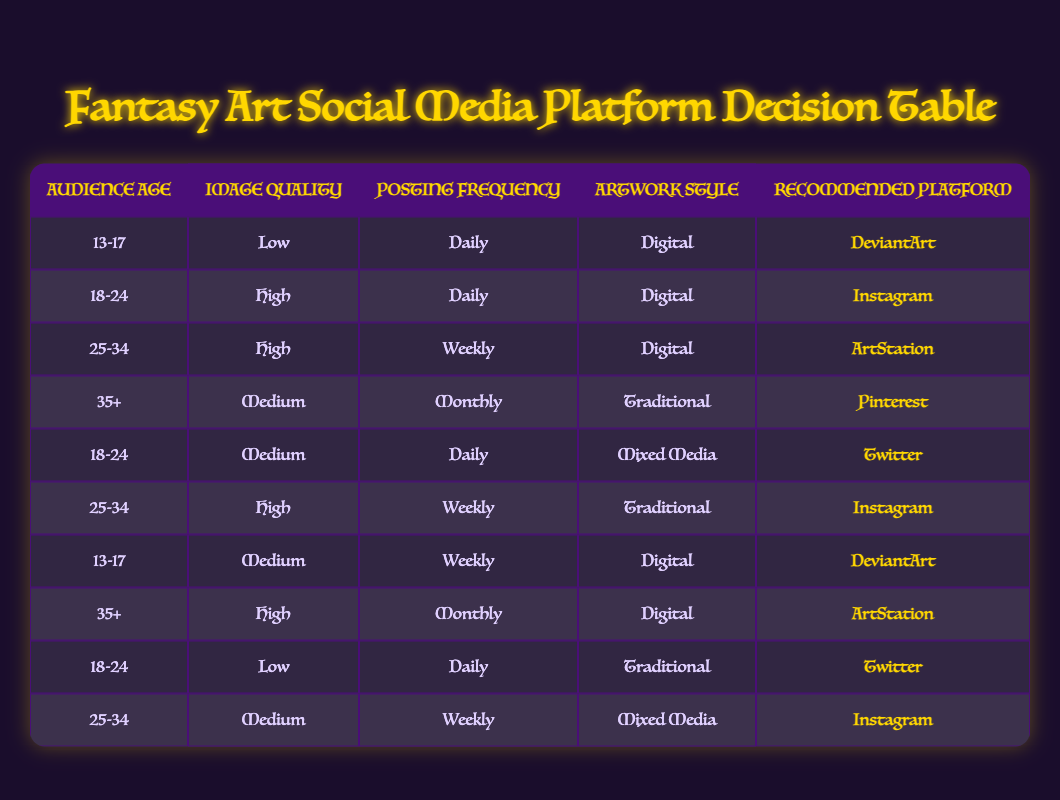What is the recommended platform for 18-24 age group with high image quality and daily posting frequency? According to the table, the conditions match the second row where the audiences are aged 18-24, with high image quality, and posting daily. The recommended platform is Instagram.
Answer: Instagram Which age group is advised to use Pinterest for sharing artwork? Looking at the table, Pinterest is suggested for the 35+ age group with medium image quality and monthly posting frequency, as seen in the fourth row.
Answer: 35+ Is there a recommended platform for 25-34 age group with medium quality and weekly posting frequency? In the table, there is no specific entry for the 25-34 age group with medium quality and weekly frequency; thus, no recommendation exists under these conditions.
Answer: No How many rows suggest DeviantArt as the recommended platform? By counting the rows with DeviantArt in the fifth column, we find two entries: one for 13-17 years with low quality and daily posting, and the other for 13-17 years with medium quality and weekly posting. So, there are two rows suggesting DeviantArt.
Answer: 2 Compare the platforms suggested for digital artwork versus traditional artwork. Which platform is recommended for higher age groups in each artwork style? For digital artwork, the platforms suggested for higher age groups (25-34 and 35+) include ArtStation and Instagram, respectively. For traditional artwork, the 35+ age group is directed towards Pinterest. Thus, Instagram is recommended for higher groups in digital art, and Pinterest in traditional art.
Answer: Instagram for digital, Pinterest for traditional Is Twitter recommended for any low image quality posts? Upon inspecting the table, two entries mention Twitter, but both pertain to Medium or High image quality. Thus, there are no recommendations for low image quality posts on Twitter.
Answer: No What is the common platform recommended for 25-34 age group and high image quality across different posting frequencies? By examining the table, it's evident that for the 25-34 age group with high image quality, Instagram is the common platform recommended when posting frequency is either Weekly (fifth row) or in Traditional style (sixth row).
Answer: Instagram Does a mix of media style for 18-24 age group affect the platform choice? Yes, the table indicates that when the artwork style is Mixed Media for the 18-24 age group, the recommended platform is Twitter. Under other styles (Digital and Traditional), the recommendations differ as well, indicating a notable effect.
Answer: Yes What is the different posting frequency among platforms for all age groups? The data shows a variation in posting frequencies across platforms. Instagram and Twitter suggest daily and weekly frequencies, while DeviantArt and Pinterest recommend monthly posting in certain conditions. This indicates a diversity in posting schedules based on the selected platform.
Answer: Daily, Weekly, Monthly 